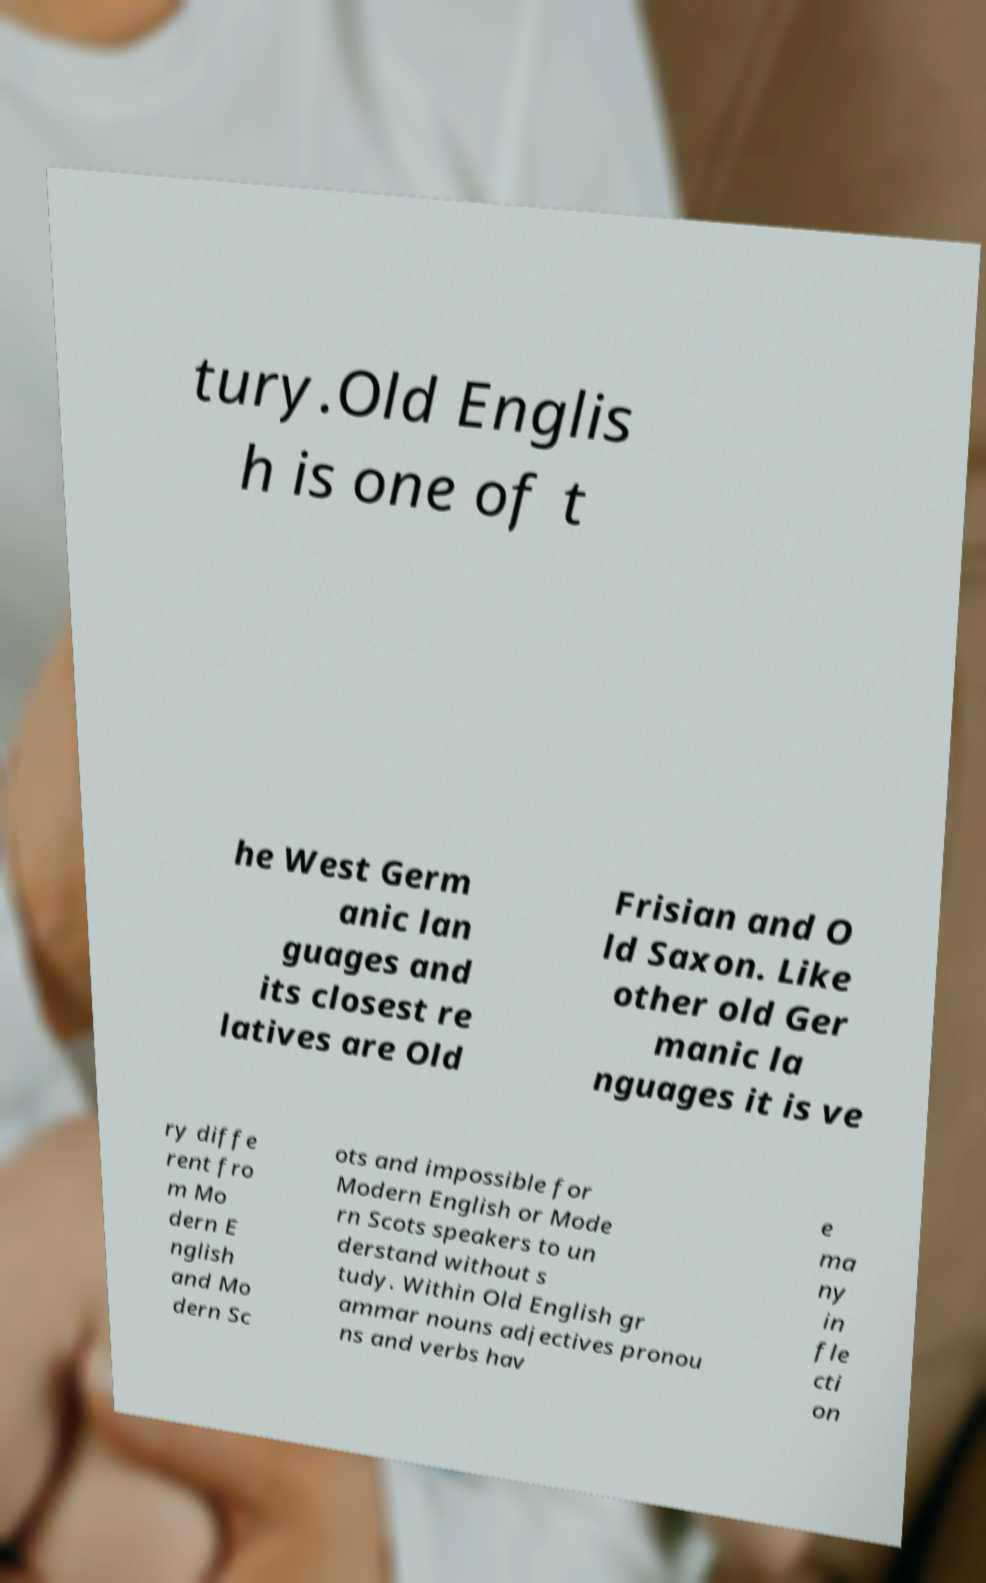What messages or text are displayed in this image? I need them in a readable, typed format. tury.Old Englis h is one of t he West Germ anic lan guages and its closest re latives are Old Frisian and O ld Saxon. Like other old Ger manic la nguages it is ve ry diffe rent fro m Mo dern E nglish and Mo dern Sc ots and impossible for Modern English or Mode rn Scots speakers to un derstand without s tudy. Within Old English gr ammar nouns adjectives pronou ns and verbs hav e ma ny in fle cti on 